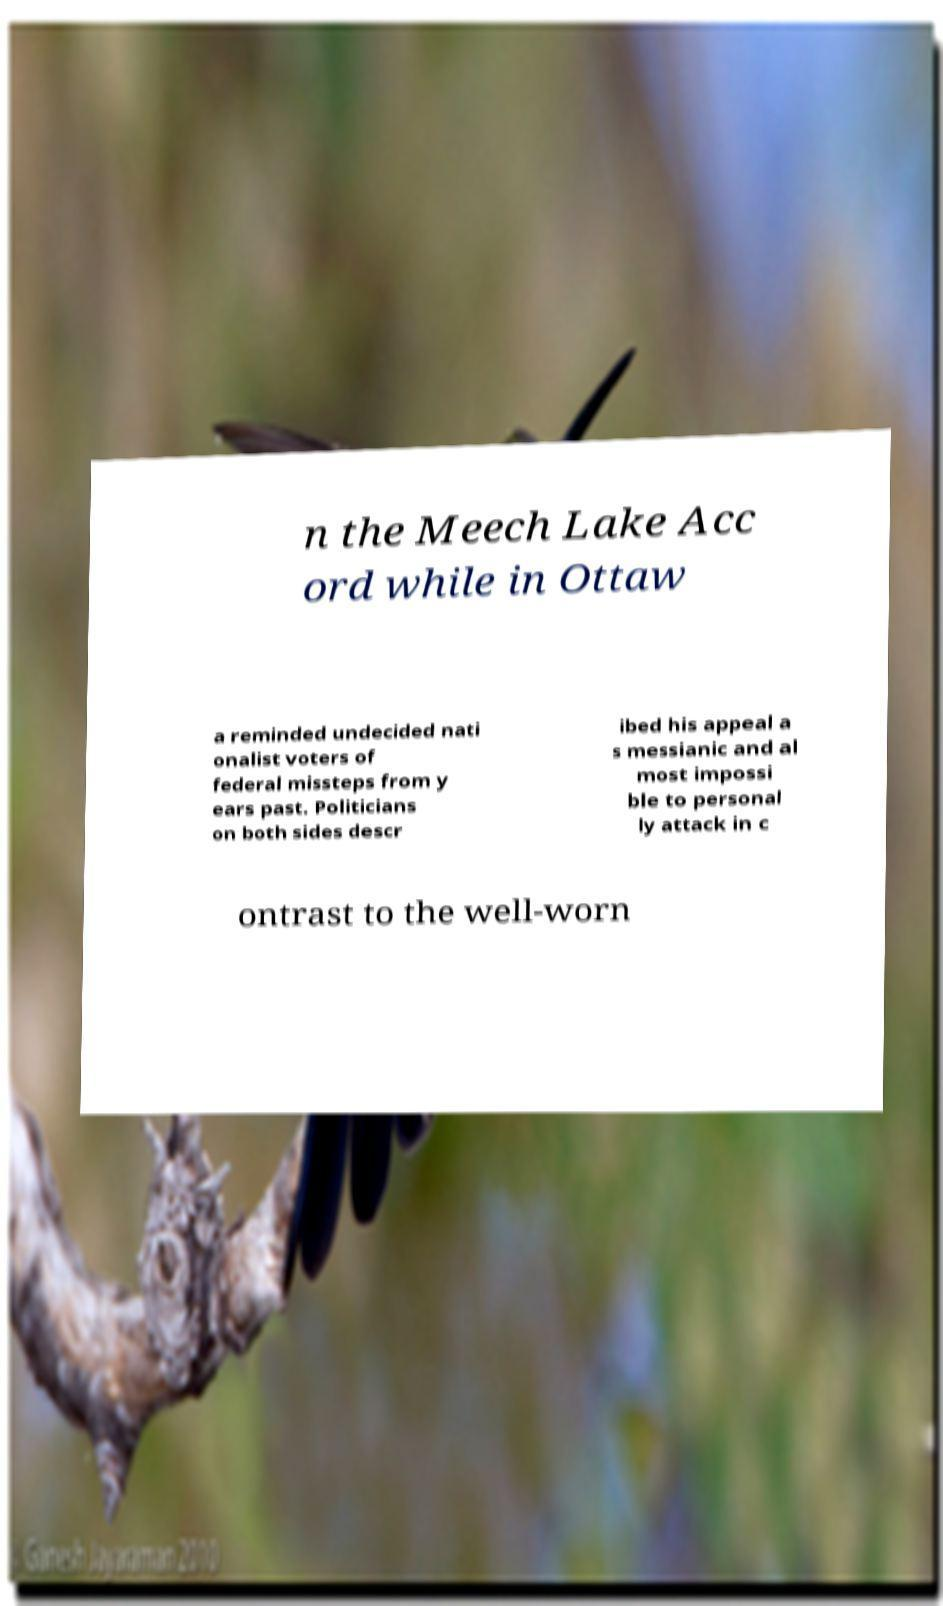Could you assist in decoding the text presented in this image and type it out clearly? n the Meech Lake Acc ord while in Ottaw a reminded undecided nati onalist voters of federal missteps from y ears past. Politicians on both sides descr ibed his appeal a s messianic and al most impossi ble to personal ly attack in c ontrast to the well-worn 